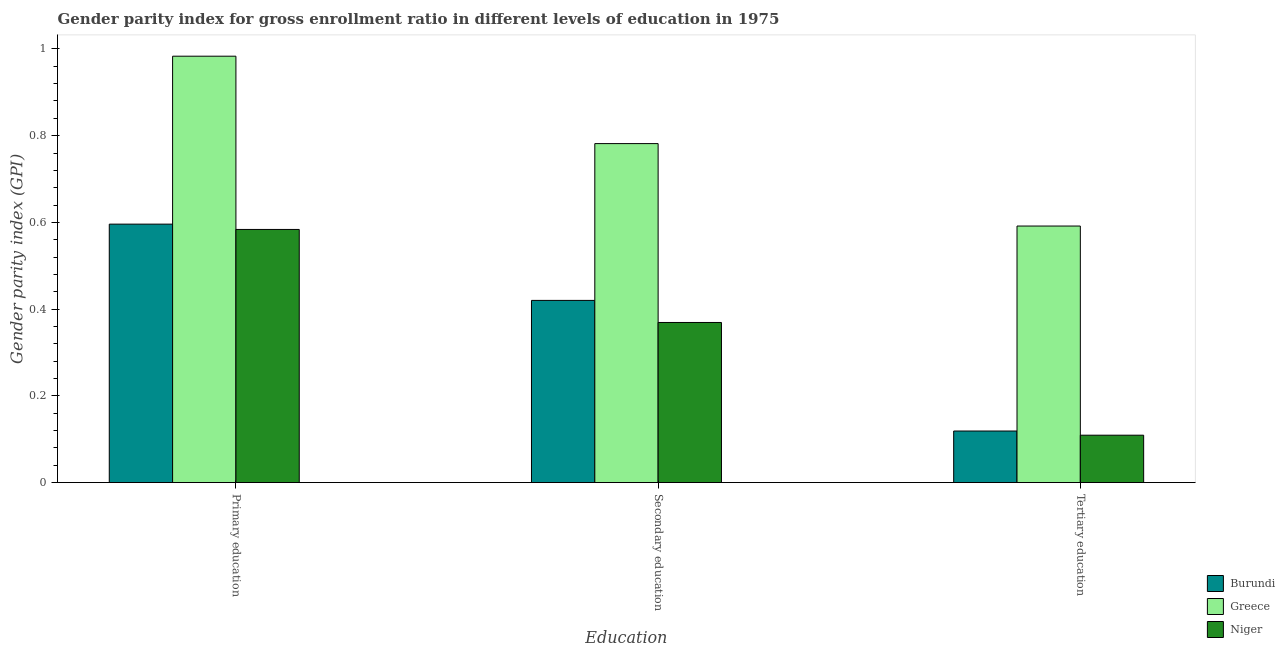How many different coloured bars are there?
Your answer should be compact. 3. How many groups of bars are there?
Keep it short and to the point. 3. Are the number of bars on each tick of the X-axis equal?
Offer a terse response. Yes. What is the gender parity index in tertiary education in Burundi?
Give a very brief answer. 0.12. Across all countries, what is the maximum gender parity index in secondary education?
Keep it short and to the point. 0.78. Across all countries, what is the minimum gender parity index in tertiary education?
Your answer should be compact. 0.11. In which country was the gender parity index in primary education maximum?
Your answer should be compact. Greece. In which country was the gender parity index in tertiary education minimum?
Provide a succinct answer. Niger. What is the total gender parity index in primary education in the graph?
Your answer should be very brief. 2.16. What is the difference between the gender parity index in secondary education in Greece and that in Niger?
Ensure brevity in your answer.  0.41. What is the difference between the gender parity index in secondary education in Niger and the gender parity index in tertiary education in Greece?
Offer a very short reply. -0.22. What is the average gender parity index in primary education per country?
Offer a very short reply. 0.72. What is the difference between the gender parity index in tertiary education and gender parity index in secondary education in Niger?
Offer a terse response. -0.26. In how many countries, is the gender parity index in secondary education greater than 0.56 ?
Keep it short and to the point. 1. What is the ratio of the gender parity index in tertiary education in Burundi to that in Greece?
Ensure brevity in your answer.  0.2. Is the difference between the gender parity index in tertiary education in Greece and Burundi greater than the difference between the gender parity index in secondary education in Greece and Burundi?
Your response must be concise. Yes. What is the difference between the highest and the second highest gender parity index in primary education?
Make the answer very short. 0.39. What is the difference between the highest and the lowest gender parity index in primary education?
Make the answer very short. 0.4. In how many countries, is the gender parity index in tertiary education greater than the average gender parity index in tertiary education taken over all countries?
Offer a very short reply. 1. Is the sum of the gender parity index in secondary education in Niger and Greece greater than the maximum gender parity index in primary education across all countries?
Provide a succinct answer. Yes. What does the 2nd bar from the left in Tertiary education represents?
Offer a very short reply. Greece. What does the 1st bar from the right in Primary education represents?
Make the answer very short. Niger. Are all the bars in the graph horizontal?
Give a very brief answer. No. How many countries are there in the graph?
Your response must be concise. 3. What is the difference between two consecutive major ticks on the Y-axis?
Provide a short and direct response. 0.2. Does the graph contain any zero values?
Keep it short and to the point. No. Where does the legend appear in the graph?
Your response must be concise. Bottom right. What is the title of the graph?
Your answer should be compact. Gender parity index for gross enrollment ratio in different levels of education in 1975. What is the label or title of the X-axis?
Offer a very short reply. Education. What is the label or title of the Y-axis?
Offer a terse response. Gender parity index (GPI). What is the Gender parity index (GPI) of Burundi in Primary education?
Keep it short and to the point. 0.6. What is the Gender parity index (GPI) of Greece in Primary education?
Keep it short and to the point. 0.98. What is the Gender parity index (GPI) of Niger in Primary education?
Your answer should be compact. 0.58. What is the Gender parity index (GPI) in Burundi in Secondary education?
Offer a very short reply. 0.42. What is the Gender parity index (GPI) of Greece in Secondary education?
Offer a very short reply. 0.78. What is the Gender parity index (GPI) of Niger in Secondary education?
Offer a terse response. 0.37. What is the Gender parity index (GPI) of Burundi in Tertiary education?
Your answer should be very brief. 0.12. What is the Gender parity index (GPI) in Greece in Tertiary education?
Make the answer very short. 0.59. What is the Gender parity index (GPI) in Niger in Tertiary education?
Make the answer very short. 0.11. Across all Education, what is the maximum Gender parity index (GPI) in Burundi?
Provide a short and direct response. 0.6. Across all Education, what is the maximum Gender parity index (GPI) of Greece?
Ensure brevity in your answer.  0.98. Across all Education, what is the maximum Gender parity index (GPI) in Niger?
Your answer should be very brief. 0.58. Across all Education, what is the minimum Gender parity index (GPI) in Burundi?
Your answer should be very brief. 0.12. Across all Education, what is the minimum Gender parity index (GPI) in Greece?
Your answer should be very brief. 0.59. Across all Education, what is the minimum Gender parity index (GPI) in Niger?
Your response must be concise. 0.11. What is the total Gender parity index (GPI) of Burundi in the graph?
Keep it short and to the point. 1.14. What is the total Gender parity index (GPI) in Greece in the graph?
Your answer should be very brief. 2.36. What is the total Gender parity index (GPI) of Niger in the graph?
Provide a succinct answer. 1.06. What is the difference between the Gender parity index (GPI) in Burundi in Primary education and that in Secondary education?
Your answer should be compact. 0.18. What is the difference between the Gender parity index (GPI) in Greece in Primary education and that in Secondary education?
Your response must be concise. 0.2. What is the difference between the Gender parity index (GPI) of Niger in Primary education and that in Secondary education?
Provide a succinct answer. 0.21. What is the difference between the Gender parity index (GPI) of Burundi in Primary education and that in Tertiary education?
Offer a very short reply. 0.48. What is the difference between the Gender parity index (GPI) of Greece in Primary education and that in Tertiary education?
Offer a very short reply. 0.39. What is the difference between the Gender parity index (GPI) in Niger in Primary education and that in Tertiary education?
Keep it short and to the point. 0.47. What is the difference between the Gender parity index (GPI) in Burundi in Secondary education and that in Tertiary education?
Ensure brevity in your answer.  0.3. What is the difference between the Gender parity index (GPI) of Greece in Secondary education and that in Tertiary education?
Make the answer very short. 0.19. What is the difference between the Gender parity index (GPI) of Niger in Secondary education and that in Tertiary education?
Your answer should be compact. 0.26. What is the difference between the Gender parity index (GPI) of Burundi in Primary education and the Gender parity index (GPI) of Greece in Secondary education?
Keep it short and to the point. -0.19. What is the difference between the Gender parity index (GPI) of Burundi in Primary education and the Gender parity index (GPI) of Niger in Secondary education?
Offer a very short reply. 0.23. What is the difference between the Gender parity index (GPI) of Greece in Primary education and the Gender parity index (GPI) of Niger in Secondary education?
Keep it short and to the point. 0.61. What is the difference between the Gender parity index (GPI) of Burundi in Primary education and the Gender parity index (GPI) of Greece in Tertiary education?
Provide a succinct answer. 0. What is the difference between the Gender parity index (GPI) of Burundi in Primary education and the Gender parity index (GPI) of Niger in Tertiary education?
Offer a terse response. 0.49. What is the difference between the Gender parity index (GPI) of Greece in Primary education and the Gender parity index (GPI) of Niger in Tertiary education?
Make the answer very short. 0.87. What is the difference between the Gender parity index (GPI) of Burundi in Secondary education and the Gender parity index (GPI) of Greece in Tertiary education?
Offer a very short reply. -0.17. What is the difference between the Gender parity index (GPI) of Burundi in Secondary education and the Gender parity index (GPI) of Niger in Tertiary education?
Offer a very short reply. 0.31. What is the difference between the Gender parity index (GPI) of Greece in Secondary education and the Gender parity index (GPI) of Niger in Tertiary education?
Your answer should be very brief. 0.67. What is the average Gender parity index (GPI) of Burundi per Education?
Ensure brevity in your answer.  0.38. What is the average Gender parity index (GPI) of Greece per Education?
Your answer should be compact. 0.79. What is the average Gender parity index (GPI) of Niger per Education?
Give a very brief answer. 0.35. What is the difference between the Gender parity index (GPI) of Burundi and Gender parity index (GPI) of Greece in Primary education?
Make the answer very short. -0.39. What is the difference between the Gender parity index (GPI) of Burundi and Gender parity index (GPI) of Niger in Primary education?
Ensure brevity in your answer.  0.01. What is the difference between the Gender parity index (GPI) in Greece and Gender parity index (GPI) in Niger in Primary education?
Give a very brief answer. 0.4. What is the difference between the Gender parity index (GPI) in Burundi and Gender parity index (GPI) in Greece in Secondary education?
Make the answer very short. -0.36. What is the difference between the Gender parity index (GPI) of Burundi and Gender parity index (GPI) of Niger in Secondary education?
Give a very brief answer. 0.05. What is the difference between the Gender parity index (GPI) of Greece and Gender parity index (GPI) of Niger in Secondary education?
Provide a succinct answer. 0.41. What is the difference between the Gender parity index (GPI) in Burundi and Gender parity index (GPI) in Greece in Tertiary education?
Provide a succinct answer. -0.47. What is the difference between the Gender parity index (GPI) of Burundi and Gender parity index (GPI) of Niger in Tertiary education?
Give a very brief answer. 0.01. What is the difference between the Gender parity index (GPI) in Greece and Gender parity index (GPI) in Niger in Tertiary education?
Your answer should be compact. 0.48. What is the ratio of the Gender parity index (GPI) in Burundi in Primary education to that in Secondary education?
Make the answer very short. 1.42. What is the ratio of the Gender parity index (GPI) of Greece in Primary education to that in Secondary education?
Provide a short and direct response. 1.26. What is the ratio of the Gender parity index (GPI) in Niger in Primary education to that in Secondary education?
Your answer should be compact. 1.58. What is the ratio of the Gender parity index (GPI) in Burundi in Primary education to that in Tertiary education?
Make the answer very short. 5.01. What is the ratio of the Gender parity index (GPI) in Greece in Primary education to that in Tertiary education?
Provide a short and direct response. 1.66. What is the ratio of the Gender parity index (GPI) of Niger in Primary education to that in Tertiary education?
Make the answer very short. 5.34. What is the ratio of the Gender parity index (GPI) in Burundi in Secondary education to that in Tertiary education?
Your response must be concise. 3.53. What is the ratio of the Gender parity index (GPI) in Greece in Secondary education to that in Tertiary education?
Offer a terse response. 1.32. What is the ratio of the Gender parity index (GPI) of Niger in Secondary education to that in Tertiary education?
Keep it short and to the point. 3.38. What is the difference between the highest and the second highest Gender parity index (GPI) in Burundi?
Provide a short and direct response. 0.18. What is the difference between the highest and the second highest Gender parity index (GPI) in Greece?
Ensure brevity in your answer.  0.2. What is the difference between the highest and the second highest Gender parity index (GPI) of Niger?
Your answer should be very brief. 0.21. What is the difference between the highest and the lowest Gender parity index (GPI) in Burundi?
Provide a succinct answer. 0.48. What is the difference between the highest and the lowest Gender parity index (GPI) of Greece?
Offer a very short reply. 0.39. What is the difference between the highest and the lowest Gender parity index (GPI) of Niger?
Ensure brevity in your answer.  0.47. 